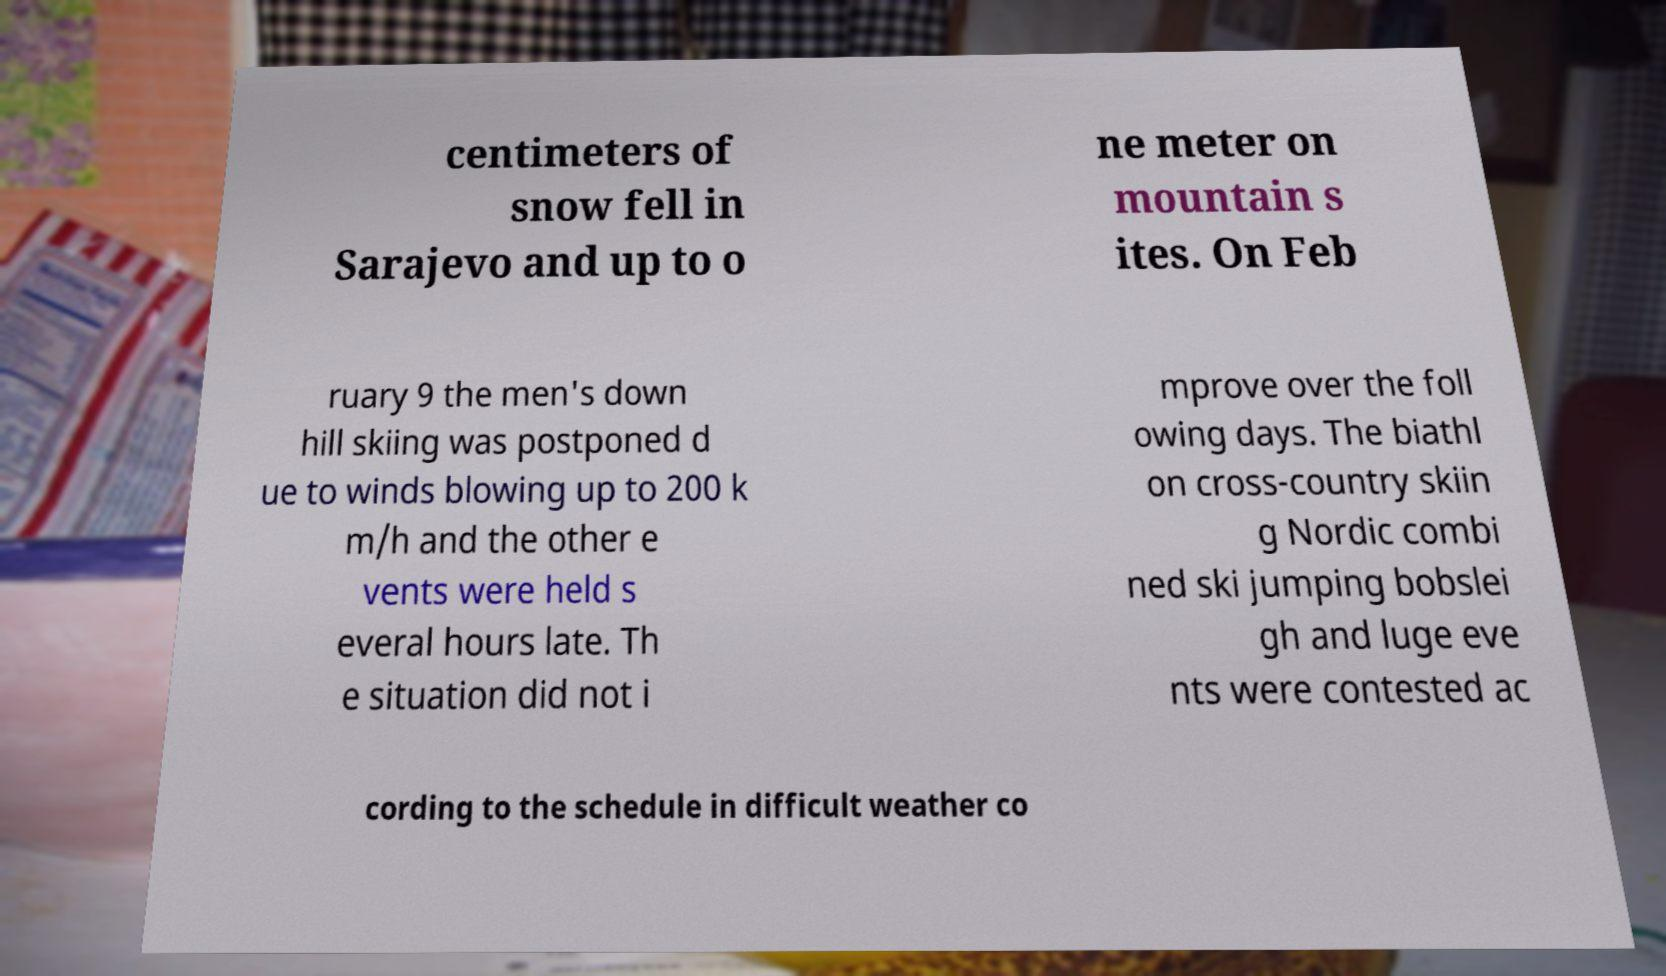Could you extract and type out the text from this image? centimeters of snow fell in Sarajevo and up to o ne meter on mountain s ites. On Feb ruary 9 the men's down hill skiing was postponed d ue to winds blowing up to 200 k m/h and the other e vents were held s everal hours late. Th e situation did not i mprove over the foll owing days. The biathl on cross-country skiin g Nordic combi ned ski jumping bobslei gh and luge eve nts were contested ac cording to the schedule in difficult weather co 